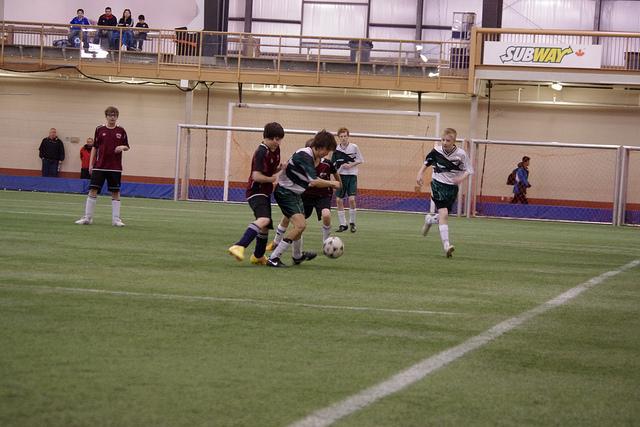What color is the line on the field?
Short answer required. White. Are they outside?
Keep it brief. No. What sport are the children playing?
Write a very short answer. Soccer. 